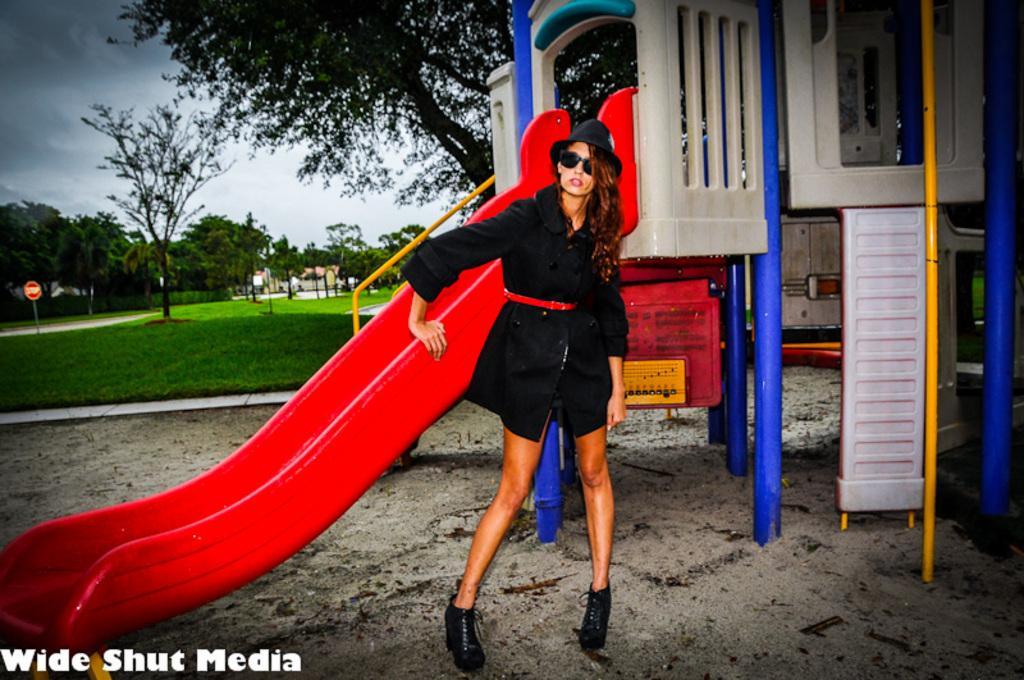Can you describe this image briefly? In this image in the front there is a woman standing. In the center there is an object which is red, blue and white in colour and there are rods which are orange in colour. In the background there are trees, there is grass on the ground and there are poles and the sky is cloudy. 